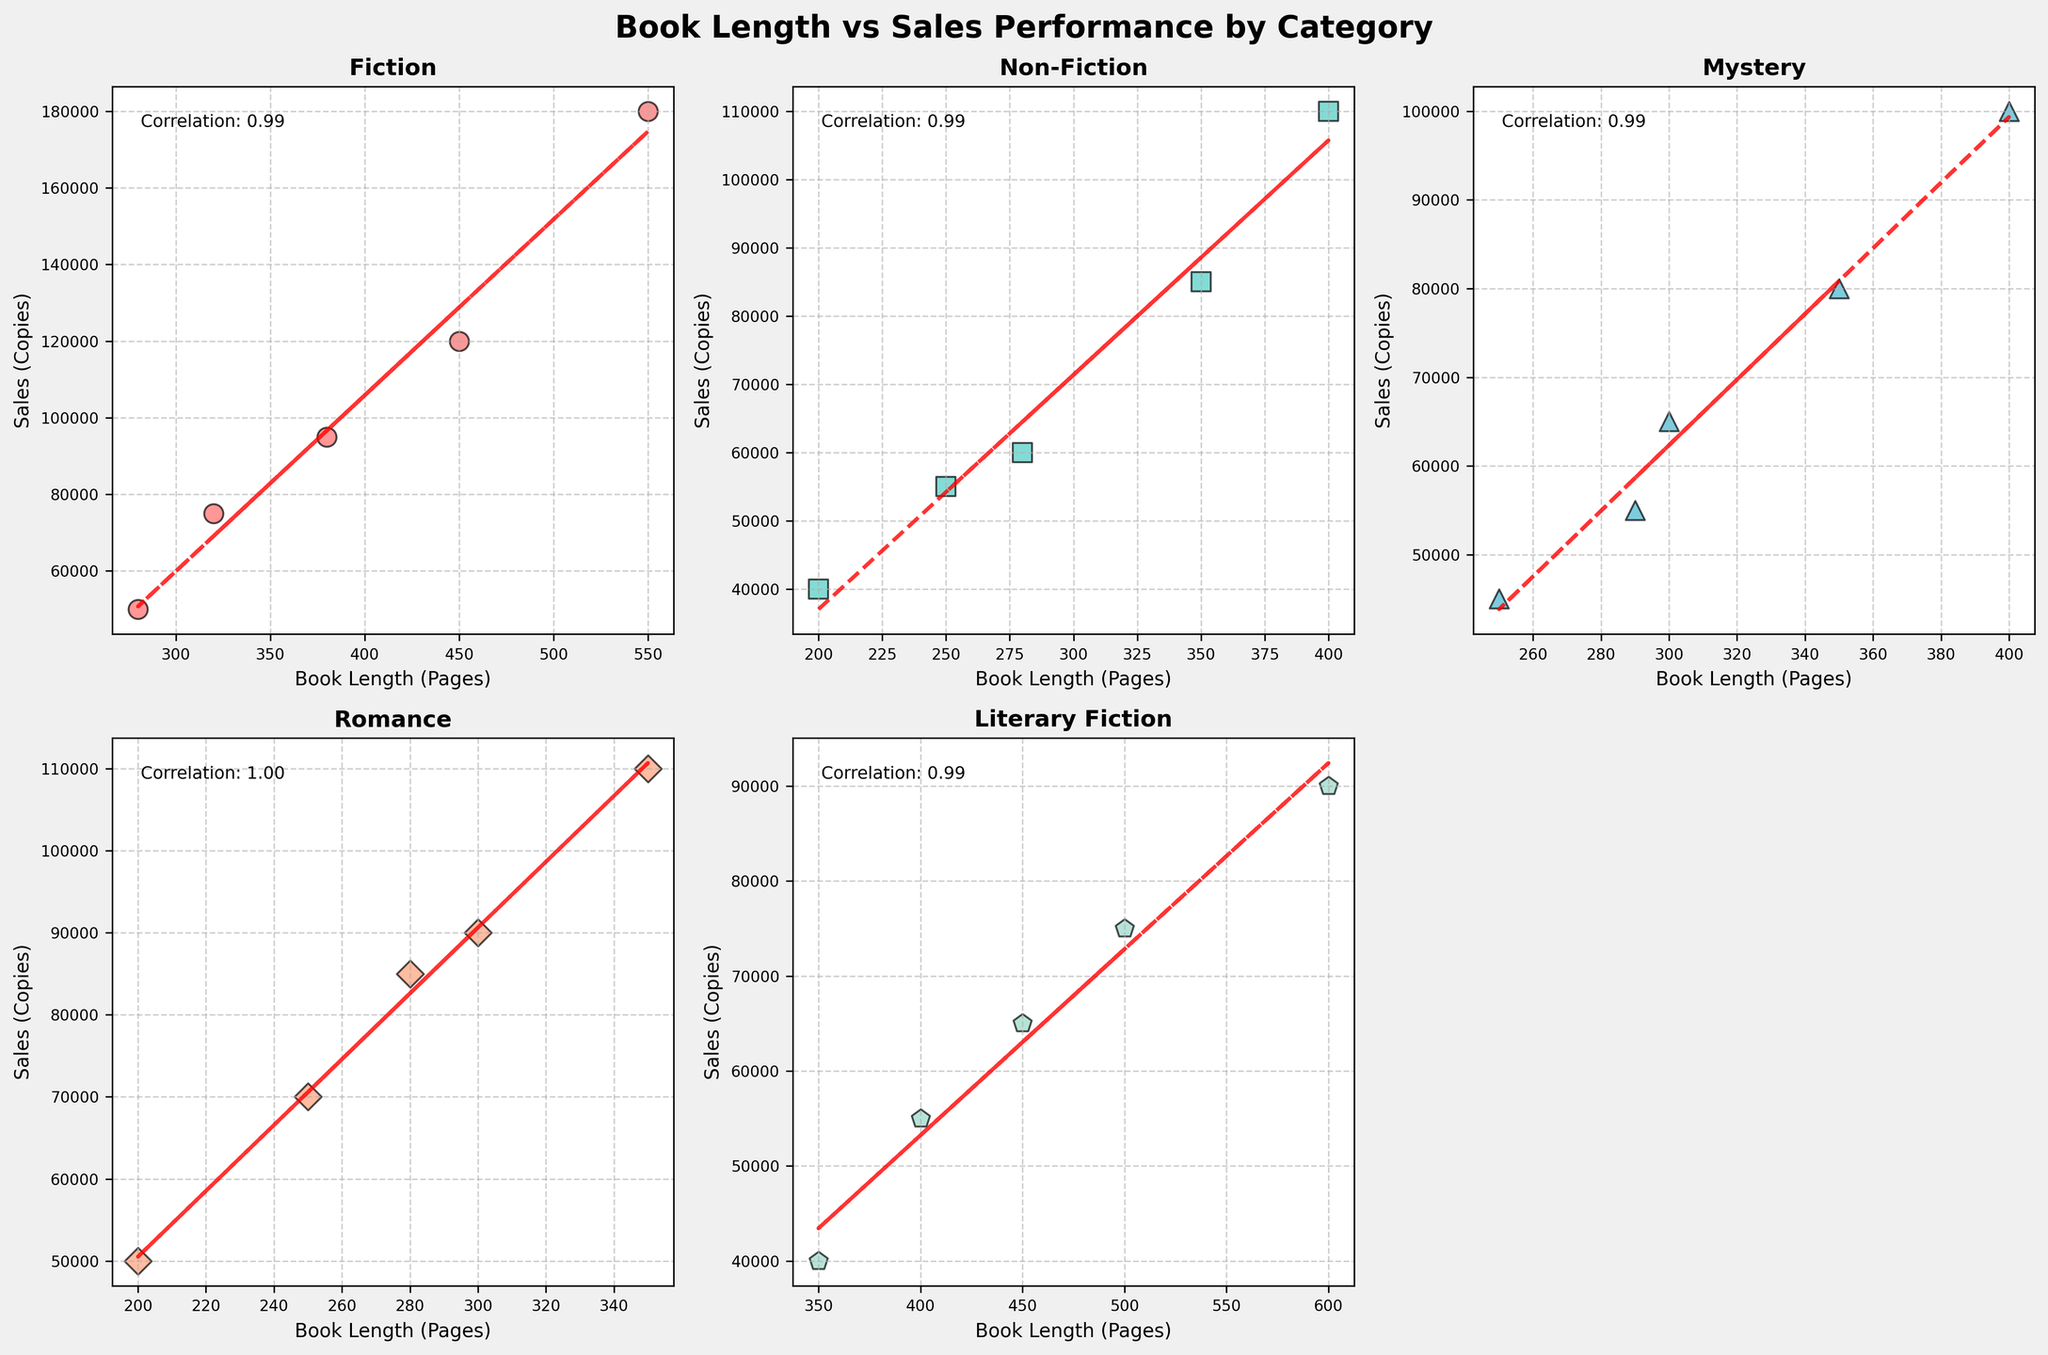What is the title of the figure? The title is prominently displayed at the top of the figure, detailing the focus. It reads "Book Length vs Sales Performance by Category".
Answer: Book Length vs Sales Performance by Category How many categories are showcased in the figure? There are six subplots in the figure, each representing a different category. One subplot is left blank, meaning there are five categories.
Answer: 5 Which category has the highest correlation between book length and sales? We need to look at the correlation values annotated in each subplot and identify the highest one. From the figure, the Mystery category has the highest correlation coefficient.
Answer: Mystery In which category do we see the steepest trend line? Observing the inclination of the trend lines in each subplot and comparing their slopes, the Fiction category displays the steepest ascending trend line.
Answer: Fiction Compare the average sales for Fiction and Non-Fiction. First, we identify the data points for each category and calculate their average sales. Fiction has sales of (75000 + 120000 + 50000 + 180000 + 95000) / 5 = 104000, and Non-Fiction has sales of (40000 + 85000 + 60000 + 110000 + 55000) / 5 = 70000.
Answer: Fiction: 104000, Non-Fiction: 70000 Which category has the most significant spread in book lengths? By checking the range of book length data points (difference between maximum and minimum values) in each category’s subplot. The Fiction category ranges from 280 to 550 pages.
Answer: Fiction How does the book length affect sales in Romance compared to Literary Fiction? We compare the shape and direction of the scatter plots and trend lines for these categories. Romance has a more noticeable positive correlation with book length than Literary Fiction.
Answer: Positive correlation in Romance Which category has the lowest average sales? Calculate the mean sales for each category and compare them. Literary Fiction has sales of (55000 + 75000 + 40000 + 90000 + 65000) / 5 = 65000, which is the lowest.
Answer: Literary Fiction 